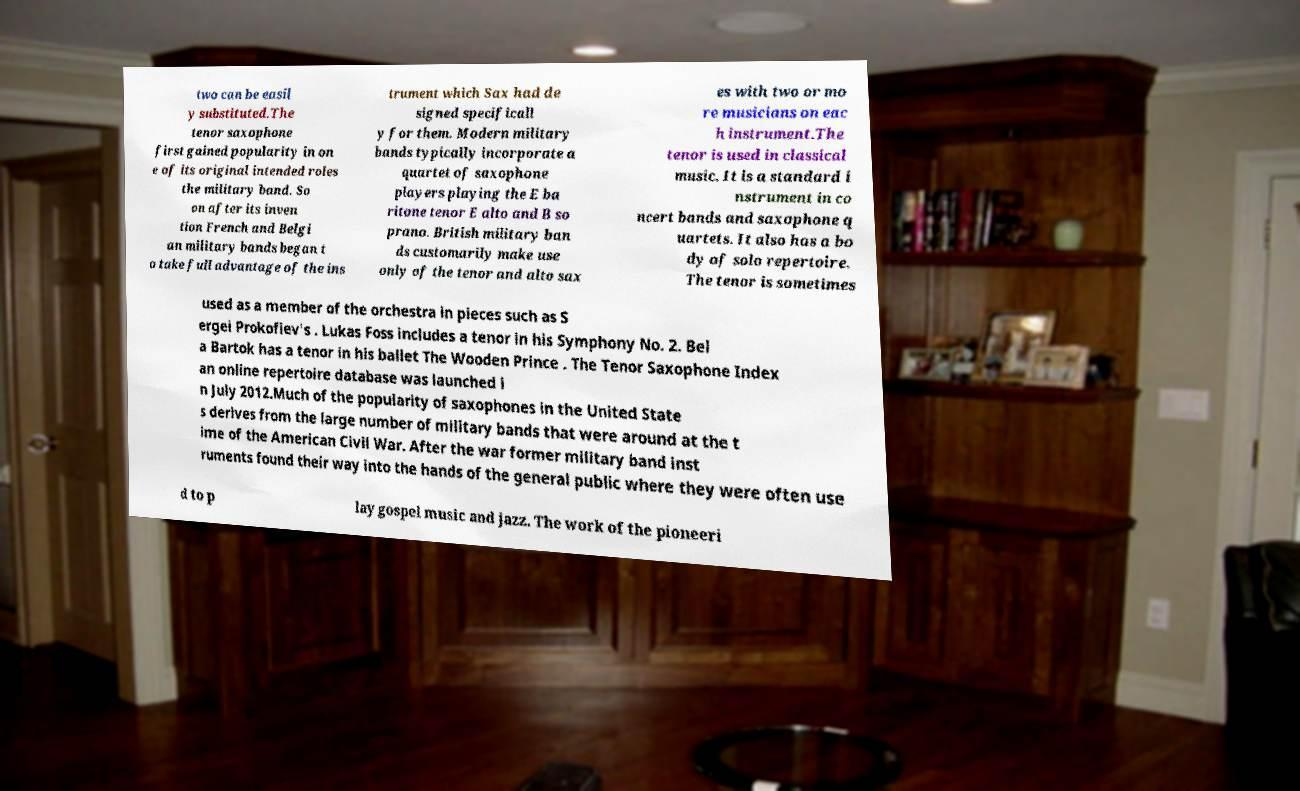Can you accurately transcribe the text from the provided image for me? two can be easil y substituted.The tenor saxophone first gained popularity in on e of its original intended roles the military band. So on after its inven tion French and Belgi an military bands began t o take full advantage of the ins trument which Sax had de signed specificall y for them. Modern military bands typically incorporate a quartet of saxophone players playing the E ba ritone tenor E alto and B so prano. British military ban ds customarily make use only of the tenor and alto sax es with two or mo re musicians on eac h instrument.The tenor is used in classical music. It is a standard i nstrument in co ncert bands and saxophone q uartets. It also has a bo dy of solo repertoire. The tenor is sometimes used as a member of the orchestra in pieces such as S ergei Prokofiev's . Lukas Foss includes a tenor in his Symphony No. 2. Bel a Bartok has a tenor in his ballet The Wooden Prince . The Tenor Saxophone Index an online repertoire database was launched i n July 2012.Much of the popularity of saxophones in the United State s derives from the large number of military bands that were around at the t ime of the American Civil War. After the war former military band inst ruments found their way into the hands of the general public where they were often use d to p lay gospel music and jazz. The work of the pioneeri 